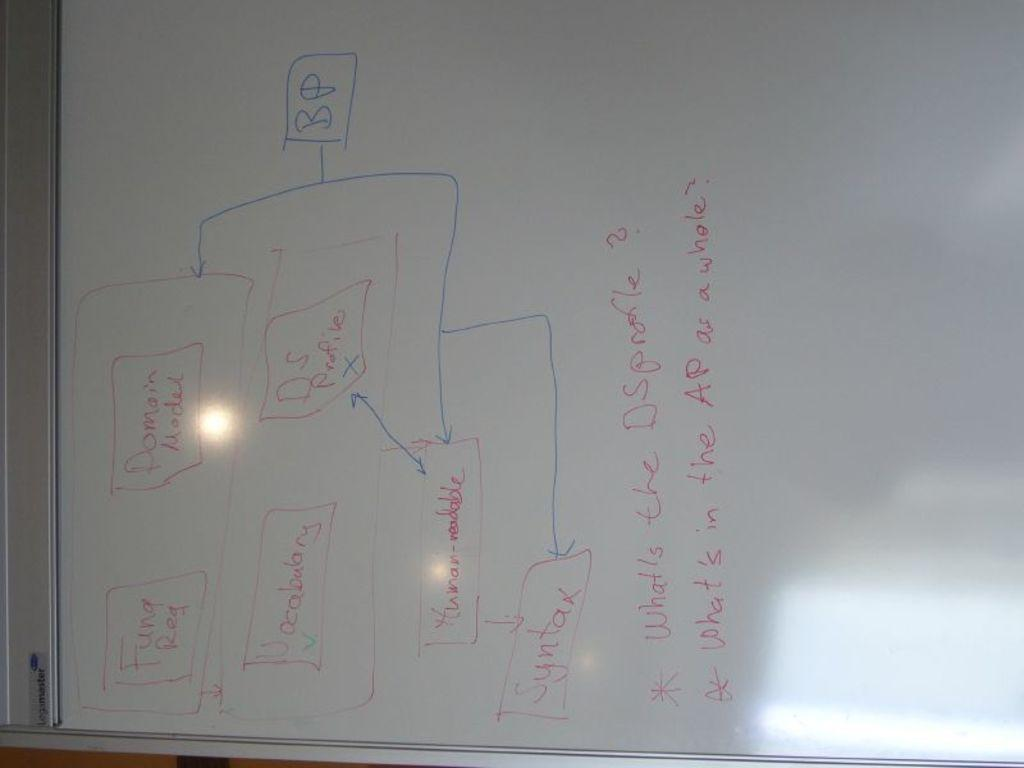<image>
Offer a succinct explanation of the picture presented. the letters BP are in a blue box on the white board 